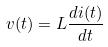<formula> <loc_0><loc_0><loc_500><loc_500>v ( t ) = L \frac { d i ( t ) } { d t }</formula> 